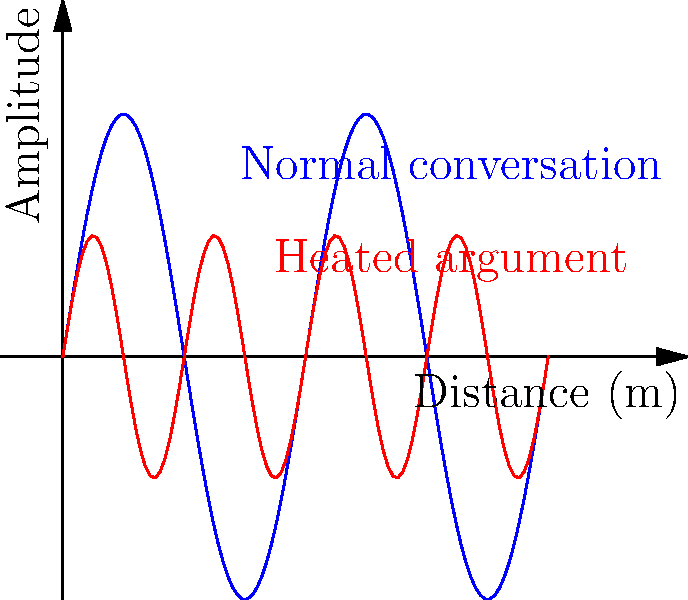During a couple's therapy session, the therapist notices that the wavelength of sound waves changes as the conversation becomes heated. If the wavelength during normal conversation is 0.5 m and the frequency remains constant at 686 Hz, what is the new wavelength when the argument intensifies and the pitch increases by one octave? Let's approach this step-by-step:

1) First, recall the relationship between wavelength ($\lambda$), frequency ($f$), and speed of sound ($v$):

   $v = f \lambda$

2) The speed of sound remains constant (assuming the room temperature doesn't change significantly).

3) During normal conversation:
   $v = 686 \text{ Hz} \times 0.5 \text{ m} = 343 \text{ m/s}$

4) When the pitch increases by one octave, the frequency doubles:
   $f_{new} = 2 \times 686 \text{ Hz} = 1372 \text{ Hz}$

5) Using the same equation with the new frequency:
   $343 \text{ m/s} = 1372 \text{ Hz} \times \lambda_{new}$

6) Solve for $\lambda_{new}$:
   $\lambda_{new} = \frac{343 \text{ m/s}}{1372 \text{ Hz}} = 0.25 \text{ m}$

Therefore, the new wavelength during the heated argument is 0.25 m.
Answer: 0.25 m 